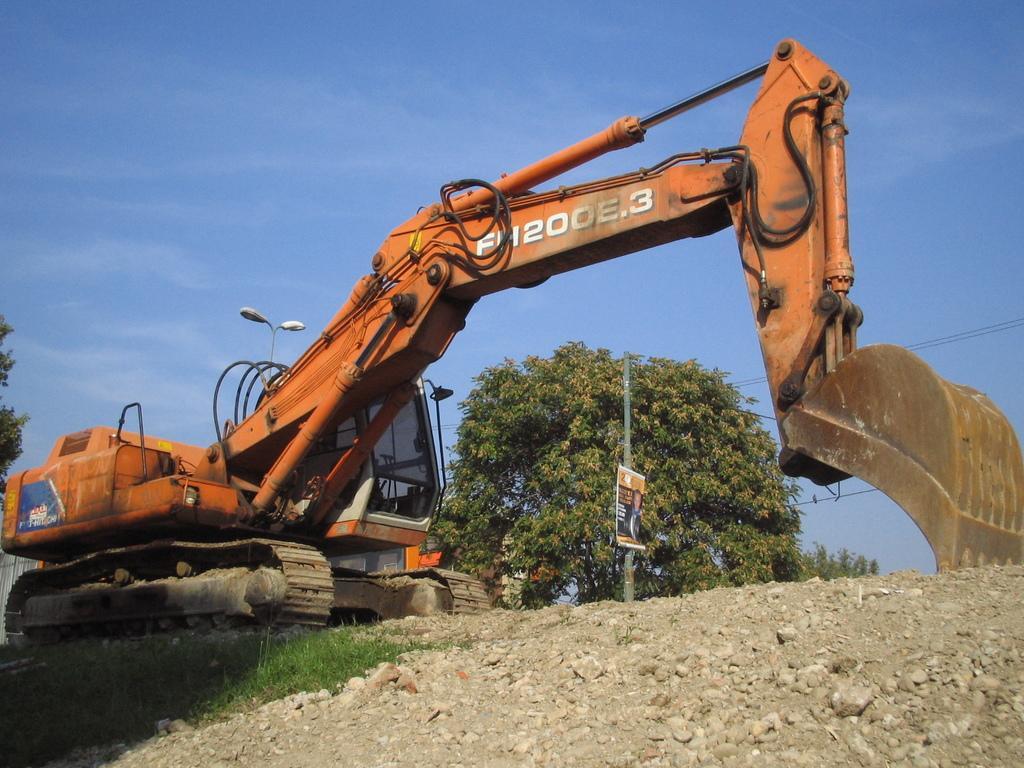In one or two sentences, can you explain what this image depicts? In the foreground of the picture there are stones, soil and grass. In the center of the picture there is a machine. In the background there are trees, street light, pole and cables. Sky is sunny. 